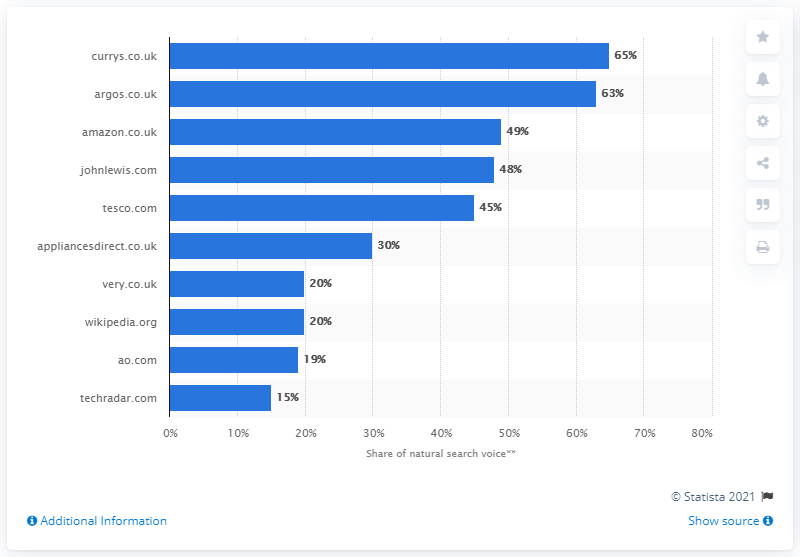Mention a couple of crucial points in this snapshot. In March 2016, argos.co.uk was ranked as the second highest website in natural search voice. 